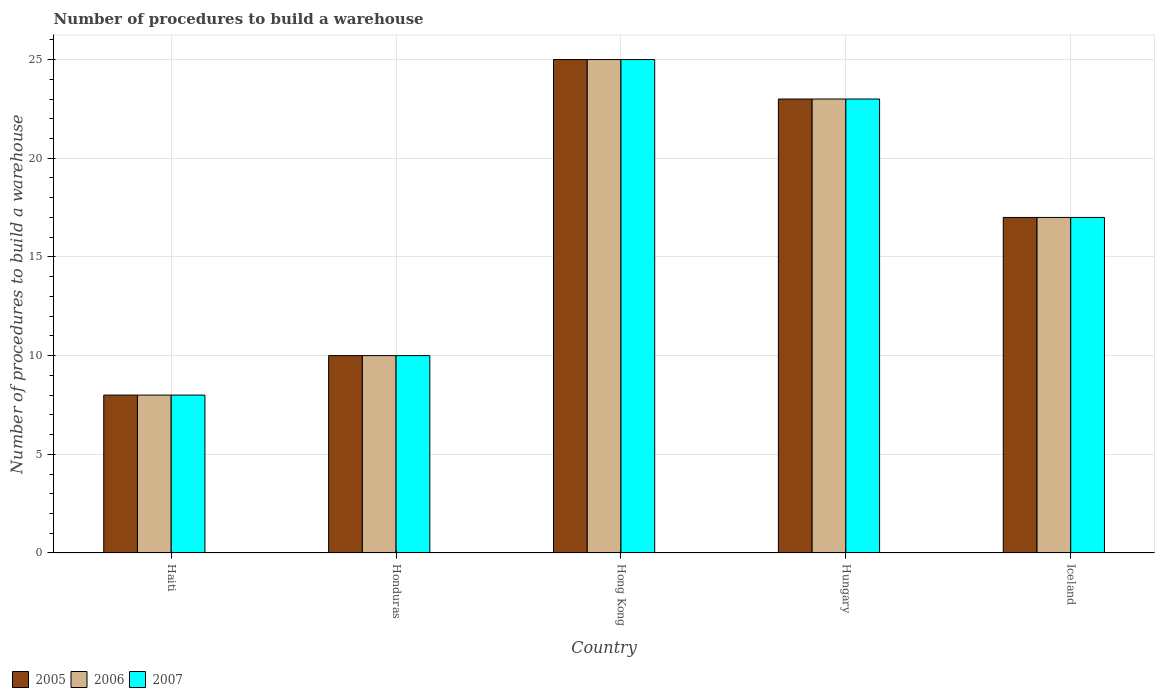How many different coloured bars are there?
Make the answer very short. 3. How many groups of bars are there?
Ensure brevity in your answer.  5. Are the number of bars per tick equal to the number of legend labels?
Provide a succinct answer. Yes. How many bars are there on the 2nd tick from the left?
Your answer should be compact. 3. How many bars are there on the 3rd tick from the right?
Give a very brief answer. 3. What is the label of the 5th group of bars from the left?
Your answer should be compact. Iceland. In how many cases, is the number of bars for a given country not equal to the number of legend labels?
Keep it short and to the point. 0. Across all countries, what is the minimum number of procedures to build a warehouse in in 2006?
Your answer should be very brief. 8. In which country was the number of procedures to build a warehouse in in 2007 maximum?
Offer a terse response. Hong Kong. In which country was the number of procedures to build a warehouse in in 2007 minimum?
Your answer should be very brief. Haiti. What is the difference between the number of procedures to build a warehouse in in 2006 in Honduras and that in Hong Kong?
Your answer should be compact. -15. What is the difference between the number of procedures to build a warehouse in of/in 2006 and number of procedures to build a warehouse in of/in 2005 in Haiti?
Provide a succinct answer. 0. Is the difference between the number of procedures to build a warehouse in in 2006 in Hungary and Iceland greater than the difference between the number of procedures to build a warehouse in in 2005 in Hungary and Iceland?
Provide a succinct answer. No. Is it the case that in every country, the sum of the number of procedures to build a warehouse in in 2005 and number of procedures to build a warehouse in in 2007 is greater than the number of procedures to build a warehouse in in 2006?
Ensure brevity in your answer.  Yes. How many bars are there?
Ensure brevity in your answer.  15. What is the difference between two consecutive major ticks on the Y-axis?
Ensure brevity in your answer.  5. Does the graph contain any zero values?
Ensure brevity in your answer.  No. Does the graph contain grids?
Provide a short and direct response. Yes. Where does the legend appear in the graph?
Your answer should be very brief. Bottom left. How many legend labels are there?
Offer a terse response. 3. How are the legend labels stacked?
Give a very brief answer. Horizontal. What is the title of the graph?
Your response must be concise. Number of procedures to build a warehouse. What is the label or title of the X-axis?
Provide a succinct answer. Country. What is the label or title of the Y-axis?
Provide a short and direct response. Number of procedures to build a warehouse. What is the Number of procedures to build a warehouse of 2005 in Haiti?
Your answer should be very brief. 8. What is the Number of procedures to build a warehouse of 2006 in Haiti?
Your answer should be compact. 8. What is the Number of procedures to build a warehouse in 2007 in Haiti?
Your response must be concise. 8. What is the Number of procedures to build a warehouse of 2007 in Honduras?
Provide a succinct answer. 10. What is the Number of procedures to build a warehouse in 2005 in Hong Kong?
Your answer should be very brief. 25. What is the Number of procedures to build a warehouse in 2007 in Hong Kong?
Keep it short and to the point. 25. What is the Number of procedures to build a warehouse of 2005 in Hungary?
Provide a short and direct response. 23. What is the Number of procedures to build a warehouse in 2007 in Hungary?
Your answer should be very brief. 23. What is the Number of procedures to build a warehouse in 2006 in Iceland?
Your response must be concise. 17. Across all countries, what is the maximum Number of procedures to build a warehouse of 2005?
Keep it short and to the point. 25. Across all countries, what is the minimum Number of procedures to build a warehouse in 2005?
Provide a succinct answer. 8. Across all countries, what is the minimum Number of procedures to build a warehouse in 2007?
Give a very brief answer. 8. What is the total Number of procedures to build a warehouse in 2005 in the graph?
Provide a short and direct response. 83. What is the total Number of procedures to build a warehouse of 2006 in the graph?
Offer a very short reply. 83. What is the total Number of procedures to build a warehouse of 2007 in the graph?
Make the answer very short. 83. What is the difference between the Number of procedures to build a warehouse of 2006 in Haiti and that in Honduras?
Offer a terse response. -2. What is the difference between the Number of procedures to build a warehouse in 2007 in Haiti and that in Honduras?
Ensure brevity in your answer.  -2. What is the difference between the Number of procedures to build a warehouse of 2006 in Haiti and that in Hong Kong?
Ensure brevity in your answer.  -17. What is the difference between the Number of procedures to build a warehouse in 2007 in Haiti and that in Hong Kong?
Ensure brevity in your answer.  -17. What is the difference between the Number of procedures to build a warehouse in 2007 in Haiti and that in Hungary?
Provide a short and direct response. -15. What is the difference between the Number of procedures to build a warehouse in 2006 in Haiti and that in Iceland?
Offer a very short reply. -9. What is the difference between the Number of procedures to build a warehouse of 2007 in Haiti and that in Iceland?
Ensure brevity in your answer.  -9. What is the difference between the Number of procedures to build a warehouse of 2007 in Honduras and that in Hong Kong?
Your answer should be compact. -15. What is the difference between the Number of procedures to build a warehouse in 2005 in Hungary and that in Iceland?
Your answer should be very brief. 6. What is the difference between the Number of procedures to build a warehouse in 2005 in Haiti and the Number of procedures to build a warehouse in 2006 in Hungary?
Your answer should be very brief. -15. What is the difference between the Number of procedures to build a warehouse in 2005 in Haiti and the Number of procedures to build a warehouse in 2007 in Hungary?
Make the answer very short. -15. What is the difference between the Number of procedures to build a warehouse in 2006 in Haiti and the Number of procedures to build a warehouse in 2007 in Hungary?
Make the answer very short. -15. What is the difference between the Number of procedures to build a warehouse of 2005 in Haiti and the Number of procedures to build a warehouse of 2006 in Iceland?
Offer a very short reply. -9. What is the difference between the Number of procedures to build a warehouse of 2005 in Honduras and the Number of procedures to build a warehouse of 2007 in Hong Kong?
Offer a very short reply. -15. What is the difference between the Number of procedures to build a warehouse of 2006 in Honduras and the Number of procedures to build a warehouse of 2007 in Hong Kong?
Your answer should be compact. -15. What is the difference between the Number of procedures to build a warehouse in 2005 in Honduras and the Number of procedures to build a warehouse in 2007 in Hungary?
Your answer should be compact. -13. What is the difference between the Number of procedures to build a warehouse in 2006 in Honduras and the Number of procedures to build a warehouse in 2007 in Hungary?
Ensure brevity in your answer.  -13. What is the difference between the Number of procedures to build a warehouse in 2005 in Honduras and the Number of procedures to build a warehouse in 2006 in Iceland?
Keep it short and to the point. -7. What is the difference between the Number of procedures to build a warehouse in 2005 in Honduras and the Number of procedures to build a warehouse in 2007 in Iceland?
Keep it short and to the point. -7. What is the difference between the Number of procedures to build a warehouse in 2006 in Honduras and the Number of procedures to build a warehouse in 2007 in Iceland?
Your answer should be very brief. -7. What is the difference between the Number of procedures to build a warehouse in 2005 in Hong Kong and the Number of procedures to build a warehouse in 2007 in Hungary?
Provide a succinct answer. 2. What is the difference between the Number of procedures to build a warehouse in 2005 in Hungary and the Number of procedures to build a warehouse in 2006 in Iceland?
Your answer should be very brief. 6. What is the difference between the Number of procedures to build a warehouse in 2006 in Hungary and the Number of procedures to build a warehouse in 2007 in Iceland?
Offer a terse response. 6. What is the average Number of procedures to build a warehouse in 2006 per country?
Keep it short and to the point. 16.6. What is the average Number of procedures to build a warehouse of 2007 per country?
Give a very brief answer. 16.6. What is the difference between the Number of procedures to build a warehouse of 2005 and Number of procedures to build a warehouse of 2006 in Honduras?
Make the answer very short. 0. What is the difference between the Number of procedures to build a warehouse of 2005 and Number of procedures to build a warehouse of 2007 in Honduras?
Ensure brevity in your answer.  0. What is the difference between the Number of procedures to build a warehouse in 2006 and Number of procedures to build a warehouse in 2007 in Honduras?
Your answer should be compact. 0. What is the difference between the Number of procedures to build a warehouse in 2005 and Number of procedures to build a warehouse in 2006 in Hungary?
Your answer should be compact. 0. What is the difference between the Number of procedures to build a warehouse in 2005 and Number of procedures to build a warehouse in 2006 in Iceland?
Keep it short and to the point. 0. What is the difference between the Number of procedures to build a warehouse of 2006 and Number of procedures to build a warehouse of 2007 in Iceland?
Your answer should be very brief. 0. What is the ratio of the Number of procedures to build a warehouse in 2005 in Haiti to that in Honduras?
Provide a succinct answer. 0.8. What is the ratio of the Number of procedures to build a warehouse of 2007 in Haiti to that in Honduras?
Make the answer very short. 0.8. What is the ratio of the Number of procedures to build a warehouse in 2005 in Haiti to that in Hong Kong?
Offer a very short reply. 0.32. What is the ratio of the Number of procedures to build a warehouse of 2006 in Haiti to that in Hong Kong?
Your response must be concise. 0.32. What is the ratio of the Number of procedures to build a warehouse in 2007 in Haiti to that in Hong Kong?
Your answer should be compact. 0.32. What is the ratio of the Number of procedures to build a warehouse of 2005 in Haiti to that in Hungary?
Provide a succinct answer. 0.35. What is the ratio of the Number of procedures to build a warehouse in 2006 in Haiti to that in Hungary?
Provide a short and direct response. 0.35. What is the ratio of the Number of procedures to build a warehouse in 2007 in Haiti to that in Hungary?
Your answer should be very brief. 0.35. What is the ratio of the Number of procedures to build a warehouse of 2005 in Haiti to that in Iceland?
Make the answer very short. 0.47. What is the ratio of the Number of procedures to build a warehouse in 2006 in Haiti to that in Iceland?
Give a very brief answer. 0.47. What is the ratio of the Number of procedures to build a warehouse in 2007 in Haiti to that in Iceland?
Your response must be concise. 0.47. What is the ratio of the Number of procedures to build a warehouse of 2006 in Honduras to that in Hong Kong?
Provide a short and direct response. 0.4. What is the ratio of the Number of procedures to build a warehouse in 2007 in Honduras to that in Hong Kong?
Offer a very short reply. 0.4. What is the ratio of the Number of procedures to build a warehouse in 2005 in Honduras to that in Hungary?
Keep it short and to the point. 0.43. What is the ratio of the Number of procedures to build a warehouse of 2006 in Honduras to that in Hungary?
Your response must be concise. 0.43. What is the ratio of the Number of procedures to build a warehouse of 2007 in Honduras to that in Hungary?
Offer a terse response. 0.43. What is the ratio of the Number of procedures to build a warehouse in 2005 in Honduras to that in Iceland?
Provide a succinct answer. 0.59. What is the ratio of the Number of procedures to build a warehouse in 2006 in Honduras to that in Iceland?
Provide a short and direct response. 0.59. What is the ratio of the Number of procedures to build a warehouse in 2007 in Honduras to that in Iceland?
Ensure brevity in your answer.  0.59. What is the ratio of the Number of procedures to build a warehouse in 2005 in Hong Kong to that in Hungary?
Provide a succinct answer. 1.09. What is the ratio of the Number of procedures to build a warehouse in 2006 in Hong Kong to that in Hungary?
Offer a terse response. 1.09. What is the ratio of the Number of procedures to build a warehouse in 2007 in Hong Kong to that in Hungary?
Your response must be concise. 1.09. What is the ratio of the Number of procedures to build a warehouse in 2005 in Hong Kong to that in Iceland?
Provide a short and direct response. 1.47. What is the ratio of the Number of procedures to build a warehouse in 2006 in Hong Kong to that in Iceland?
Ensure brevity in your answer.  1.47. What is the ratio of the Number of procedures to build a warehouse of 2007 in Hong Kong to that in Iceland?
Provide a short and direct response. 1.47. What is the ratio of the Number of procedures to build a warehouse in 2005 in Hungary to that in Iceland?
Ensure brevity in your answer.  1.35. What is the ratio of the Number of procedures to build a warehouse of 2006 in Hungary to that in Iceland?
Your answer should be compact. 1.35. What is the ratio of the Number of procedures to build a warehouse of 2007 in Hungary to that in Iceland?
Provide a short and direct response. 1.35. What is the difference between the highest and the second highest Number of procedures to build a warehouse in 2005?
Provide a succinct answer. 2. What is the difference between the highest and the lowest Number of procedures to build a warehouse in 2005?
Offer a very short reply. 17. What is the difference between the highest and the lowest Number of procedures to build a warehouse of 2006?
Provide a succinct answer. 17. 